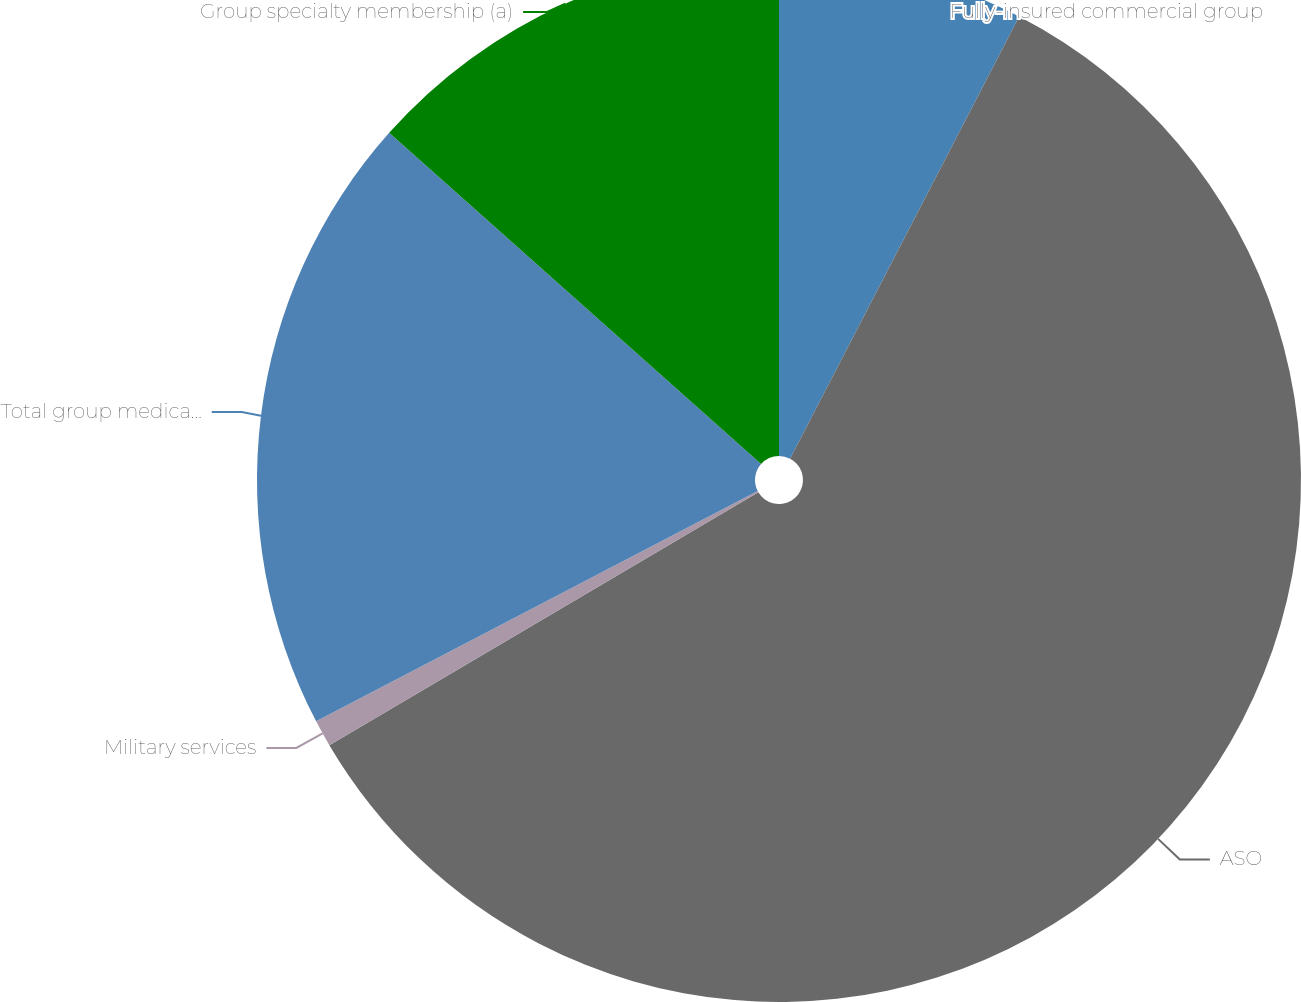<chart> <loc_0><loc_0><loc_500><loc_500><pie_chart><fcel>Fully-insured commercial group<fcel>ASO<fcel>Military services<fcel>Total group medical members<fcel>Group specialty membership (a)<nl><fcel>7.61%<fcel>58.91%<fcel>0.83%<fcel>19.23%<fcel>13.42%<nl></chart> 